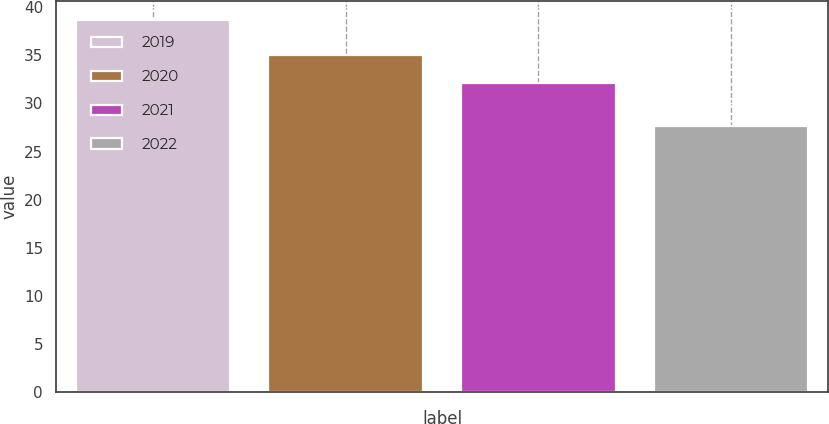Convert chart. <chart><loc_0><loc_0><loc_500><loc_500><bar_chart><fcel>2019<fcel>2020<fcel>2021<fcel>2022<nl><fcel>38.7<fcel>35.1<fcel>32.1<fcel>27.7<nl></chart> 